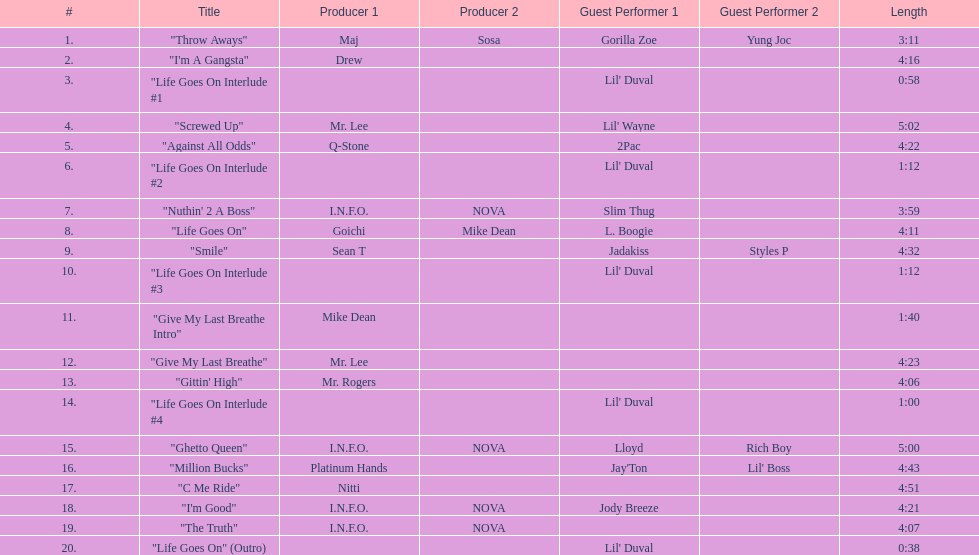How many tracks on trae's album "life goes on"? 20. 